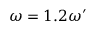<formula> <loc_0><loc_0><loc_500><loc_500>\omega = 1 . 2 \omega ^ { \prime }</formula> 